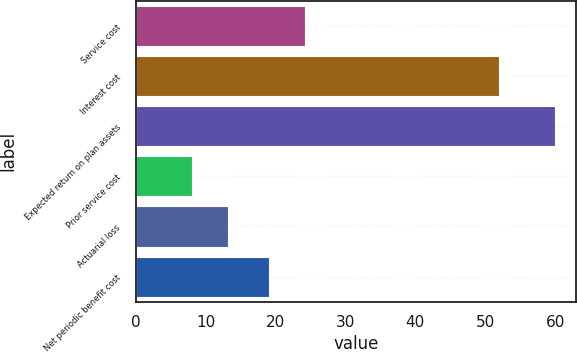Convert chart. <chart><loc_0><loc_0><loc_500><loc_500><bar_chart><fcel>Service cost<fcel>Interest cost<fcel>Expected return on plan assets<fcel>Prior service cost<fcel>Actuarial loss<fcel>Net periodic benefit cost<nl><fcel>24.2<fcel>52<fcel>60<fcel>8<fcel>13.2<fcel>19<nl></chart> 